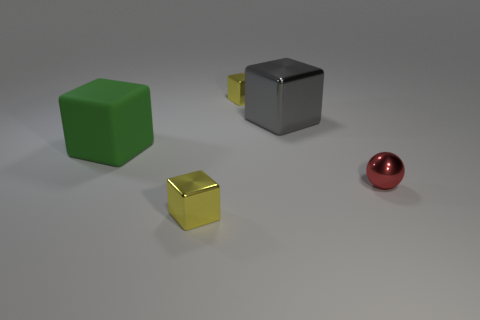There is a tiny yellow shiny thing that is behind the gray object that is left of the red thing; is there a tiny red metallic thing on the right side of it?
Provide a succinct answer. Yes. What number of tiny shiny spheres have the same color as the big rubber object?
Your answer should be very brief. 0. What shape is the rubber object that is the same size as the gray cube?
Provide a short and direct response. Cube. There is a green matte object; are there any large gray metallic cubes left of it?
Keep it short and to the point. No. Do the rubber block and the gray shiny object have the same size?
Offer a very short reply. Yes. There is a small thing that is in front of the ball; what shape is it?
Your answer should be very brief. Cube. Are there any yellow blocks that have the same size as the red thing?
Your response must be concise. Yes. There is a thing that is the same size as the rubber cube; what is it made of?
Make the answer very short. Metal. What is the size of the yellow block in front of the large green matte object?
Give a very brief answer. Small. What is the size of the matte thing?
Provide a short and direct response. Large. 